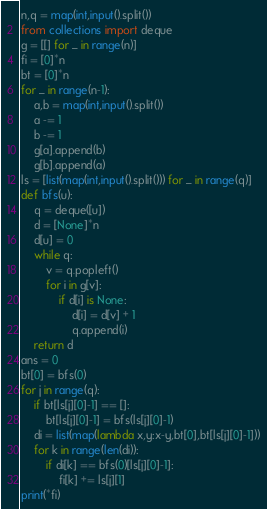Convert code to text. <code><loc_0><loc_0><loc_500><loc_500><_Python_>n,q = map(int,input().split())
from collections import deque
g = [[] for _ in range(n)]
fi = [0]*n
bt = [0]*n
for _ in range(n-1):
    a,b = map(int,input().split())
    a -= 1
    b -= 1
    g[a].append(b)
    g[b].append(a)
ls = [list(map(int,input().split())) for _ in range(q)]
def bfs(u):
    q = deque([u])
    d = [None]*n
    d[u] = 0
    while q:
        v = q.popleft()
        for i in g[v]:
            if d[i] is None:
                d[i] = d[v] + 1
                q.append(i)
    return d
ans = 0
bt[0] = bfs(0)
for j in range(q):
    if bt[ls[j][0]-1] == []:
        bt[ls[j][0]-1] = bfs(ls[j][0]-1)
    di = list(map(lambda x,y:x-y,bt[0],bt[ls[j][0]-1]))
    for k in range(len(di)):
        if di[k] == bfs(0)[ls[j][0]-1]:
            fi[k] += ls[j][1]                           
print(*fi)</code> 